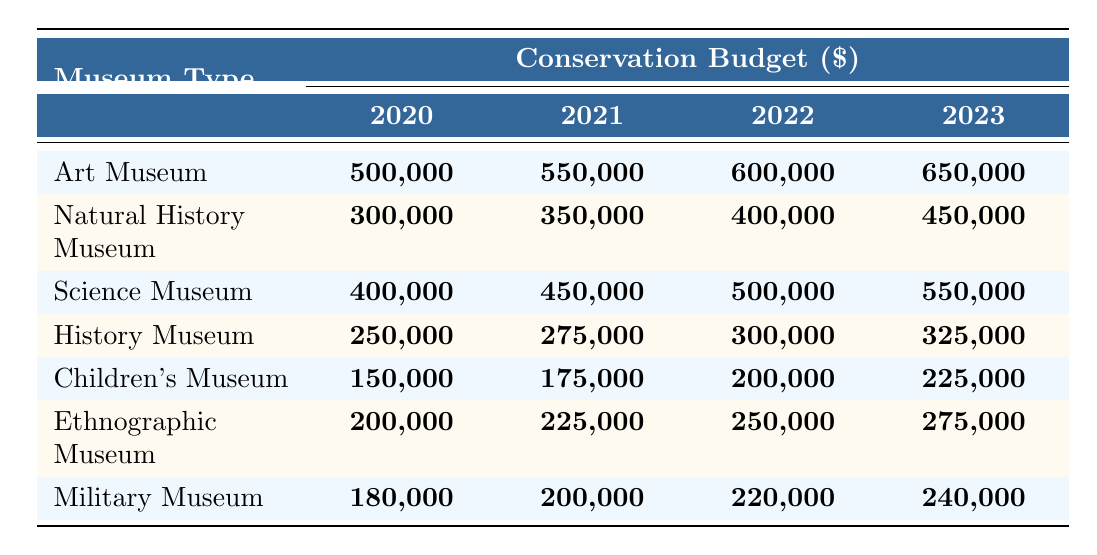What was the maximum conservation budget in 2022? The maximum budget can be found by comparing the budget values for each museum type in the year 2022. The values are: Art Museum (600,000), Natural History Museum (400,000), Science Museum (500,000), History Museum (300,000), Children's Museum (200,000), Ethnographic Museum (250,000), and Military Museum (220,000). The highest value is 600,000 from the Art Museum.
Answer: 600,000 What was the budget increase for the Natural History Museum from 2020 to 2023? To find the increase, subtract the 2020 budget (300,000) from the 2023 budget (450,000). The calculation is 450,000 - 300,000 = 150,000.
Answer: 150,000 Is the conservation budget for the Military Museum higher than that of the History Museum in 2021? The budget for the Military Museum in 2021 is 200,000 and for the History Museum, it is 275,000. Since 200,000 is less than 275,000, the statement is false.
Answer: No Which museum type had the smallest budget in 2020, and what was that budget? By examining the 2020 budgets for each museum type, we see the values: Art Museum (500,000), Natural History Museum (300,000), Science Museum (400,000), History Museum (250,000), Children's Museum (150,000), Ethnographic Museum (200,000), and Military Museum (180,000). The smallest budget is 150,000 from the Children's Museum.
Answer: Children's Museum, 150,000 What is the total conservation budget for all museums in 2023? To calculate the total budget for 2023, sum the budgets for each museum type: Art Museum (650,000) + Natural History Museum (450,000) + Science Museum (550,000) + History Museum (325,000) + Children's Museum (225,000) + Ethnographic Museum (275,000) + Military Museum (240,000). The total is 650,000 + 450,000 + 550,000 + 325,000 + 225,000 + 275,000 + 240,000 = 2,720,000.
Answer: 2,720,000 What was the average budget for the Children's Museum over the four years? The budgets for the Children's Museum are: 150,000 (2020), 175,000 (2021), 200,000 (2022), and 225,000 (2023). To find the average, sum them up: 150,000 + 175,000 + 200,000 + 225,000 = 750,000, then divide by 4 (the number of years), which is 750,000 / 4 = 187,500.
Answer: 187,500 